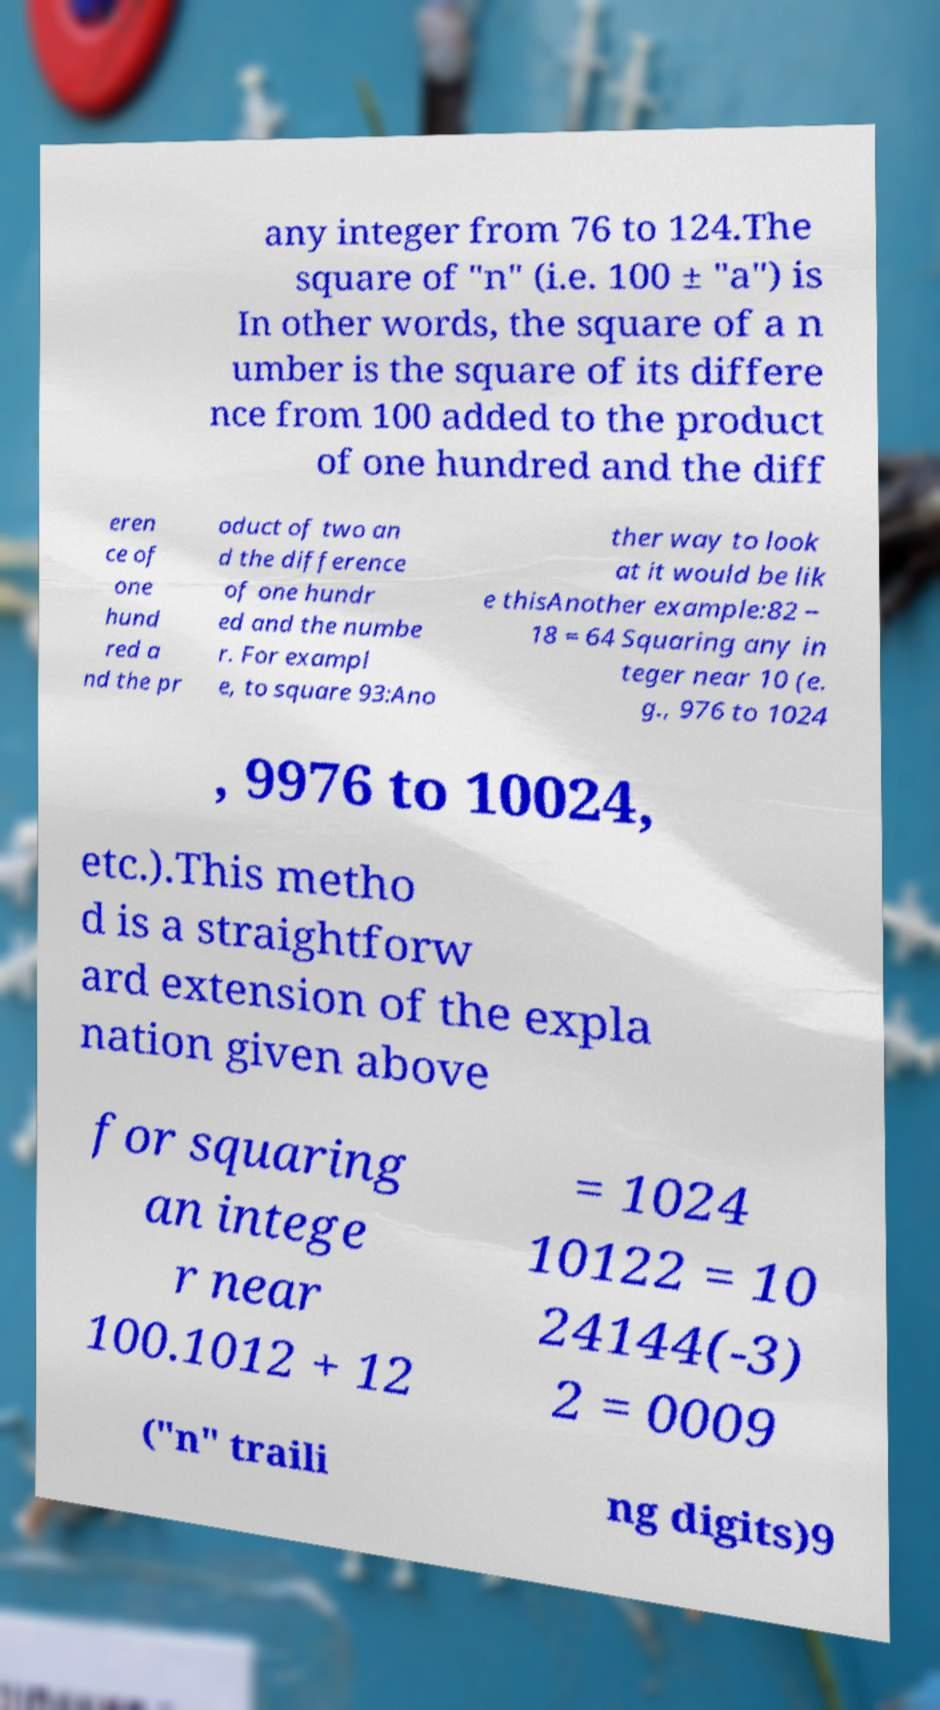I need the written content from this picture converted into text. Can you do that? any integer from 76 to 124.The square of "n" (i.e. 100 ± "a") is In other words, the square of a n umber is the square of its differe nce from 100 added to the product of one hundred and the diff eren ce of one hund red a nd the pr oduct of two an d the difference of one hundr ed and the numbe r. For exampl e, to square 93:Ano ther way to look at it would be lik e thisAnother example:82 − 18 = 64 Squaring any in teger near 10 (e. g., 976 to 1024 , 9976 to 10024, etc.).This metho d is a straightforw ard extension of the expla nation given above for squaring an intege r near 100.1012 + 12 = 1024 10122 = 10 24144(-3) 2 = 0009 ("n" traili ng digits)9 